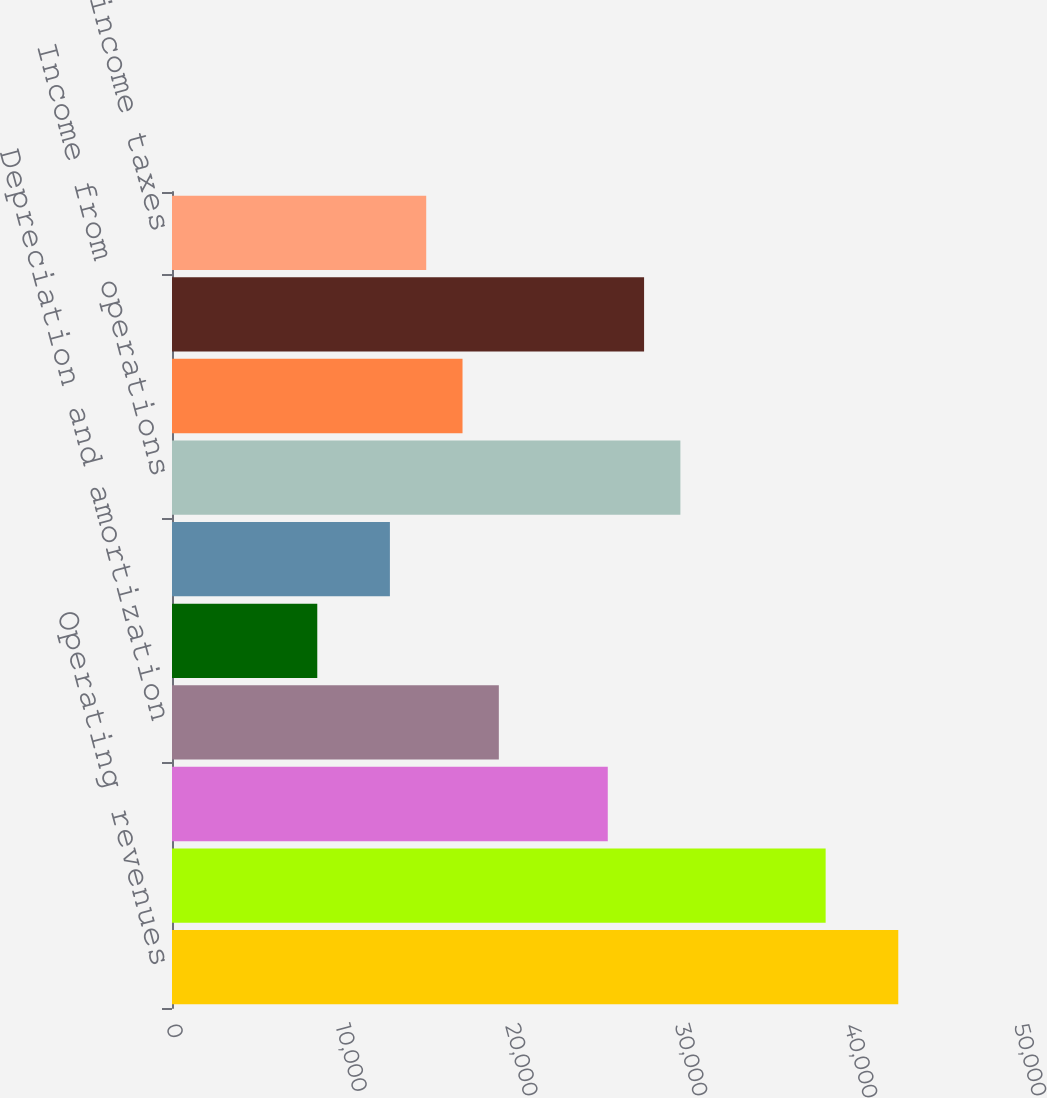Convert chart to OTSL. <chart><loc_0><loc_0><loc_500><loc_500><bar_chart><fcel>Operating revenues<fcel>Operating<fcel>Selling general and<fcel>Depreciation and amortization<fcel>Restructuring<fcel>(Income) expense from<fcel>Income from operations<fcel>Other expense net<fcel>Income before income taxes<fcel>Provision for income taxes<nl><fcel>42822.5<fcel>38540.4<fcel>25694.1<fcel>19271<fcel>8565.7<fcel>12847.8<fcel>29976.2<fcel>17129.9<fcel>27835.2<fcel>14988.9<nl></chart> 